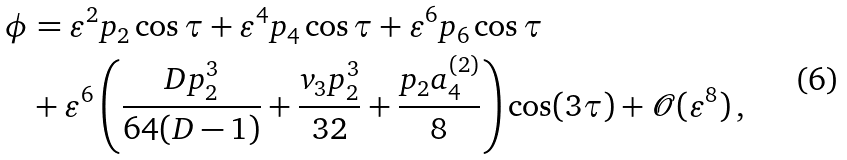Convert formula to latex. <formula><loc_0><loc_0><loc_500><loc_500>\phi & = \varepsilon ^ { 2 } p _ { 2 } \cos \tau + \varepsilon ^ { 4 } p _ { 4 } \cos \tau + \varepsilon ^ { 6 } p _ { 6 } \cos \tau \\ & + \varepsilon ^ { 6 } \left ( \frac { D p _ { 2 } ^ { 3 } } { 6 4 ( D - 1 ) } + \frac { v _ { 3 } p _ { 2 } ^ { 3 } } { 3 2 } + \frac { p _ { 2 } a _ { 4 } ^ { ( 2 ) } } { 8 } \right ) \cos ( 3 \tau ) + \mathcal { O } ( \varepsilon ^ { 8 } ) \, ,</formula> 